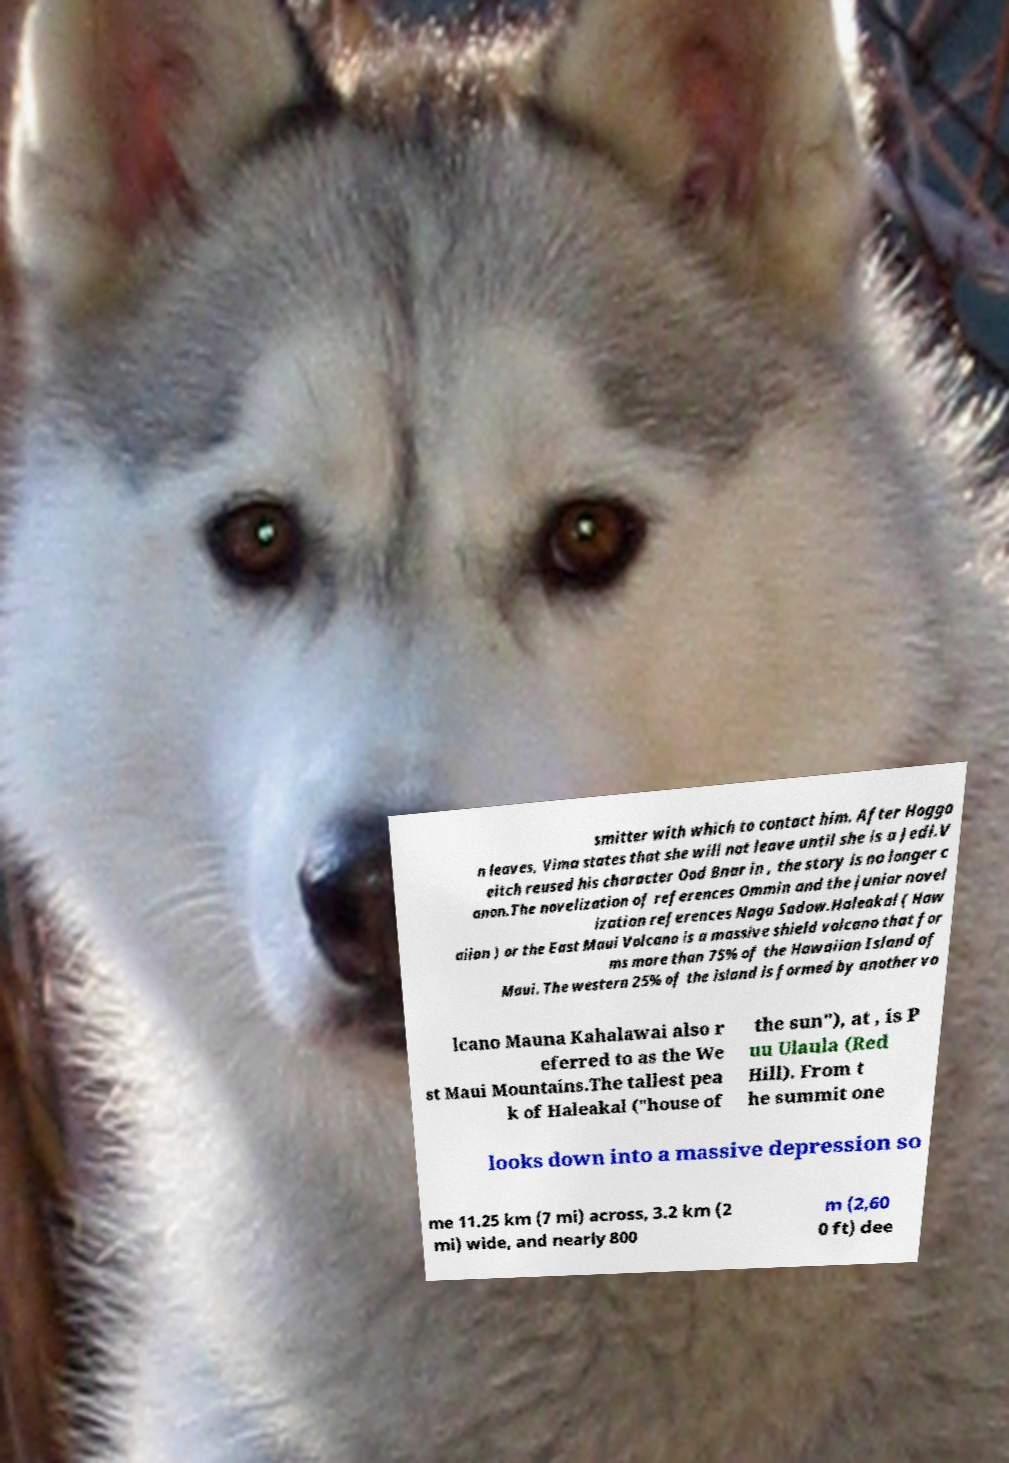There's text embedded in this image that I need extracted. Can you transcribe it verbatim? smitter with which to contact him. After Hoggo n leaves, Vima states that she will not leave until she is a Jedi.V eitch reused his character Ood Bnar in , the story is no longer c anon.The novelization of references Ommin and the junior novel ization references Naga Sadow.Haleakal ( Haw aiian ) or the East Maui Volcano is a massive shield volcano that for ms more than 75% of the Hawaiian Island of Maui. The western 25% of the island is formed by another vo lcano Mauna Kahalawai also r eferred to as the We st Maui Mountains.The tallest pea k of Haleakal ("house of the sun"), at , is P uu Ulaula (Red Hill). From t he summit one looks down into a massive depression so me 11.25 km (7 mi) across, 3.2 km (2 mi) wide, and nearly 800 m (2,60 0 ft) dee 